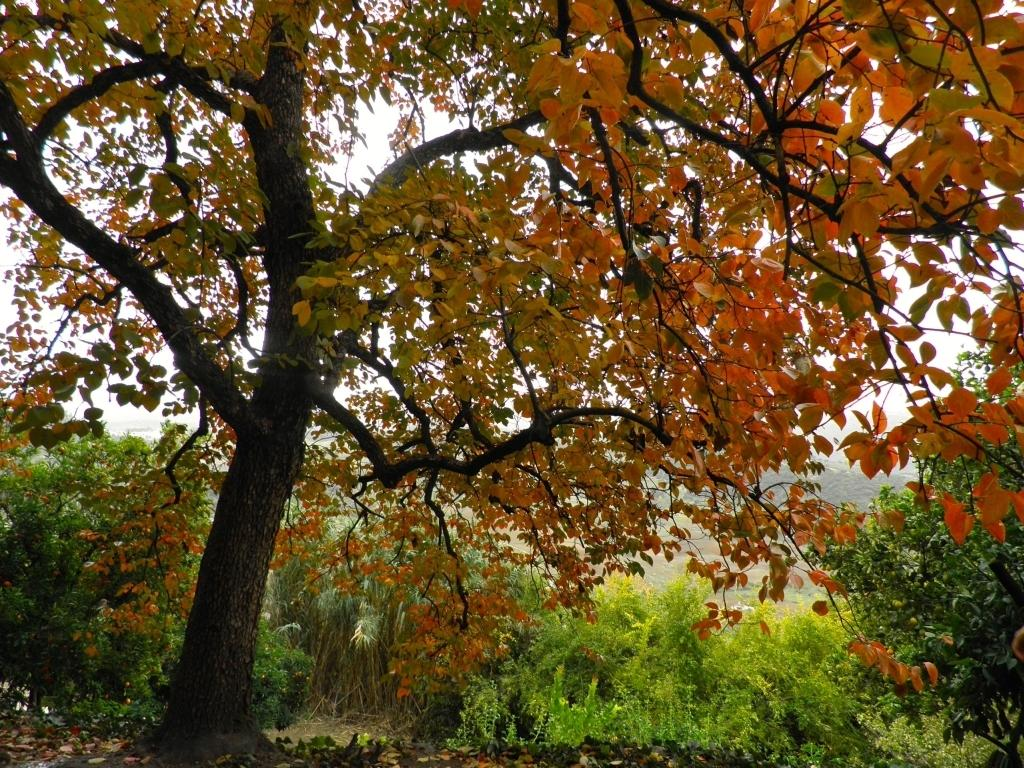What is located in the foreground of the image? There is a tree in the foreground of the image. What can be seen in the background of the image? Trees and the sky are visible in the background of the image. What type of marble is visible on the tree in the image? There is no marble present in the image; it features a tree in the foreground and trees and the sky in the background. 